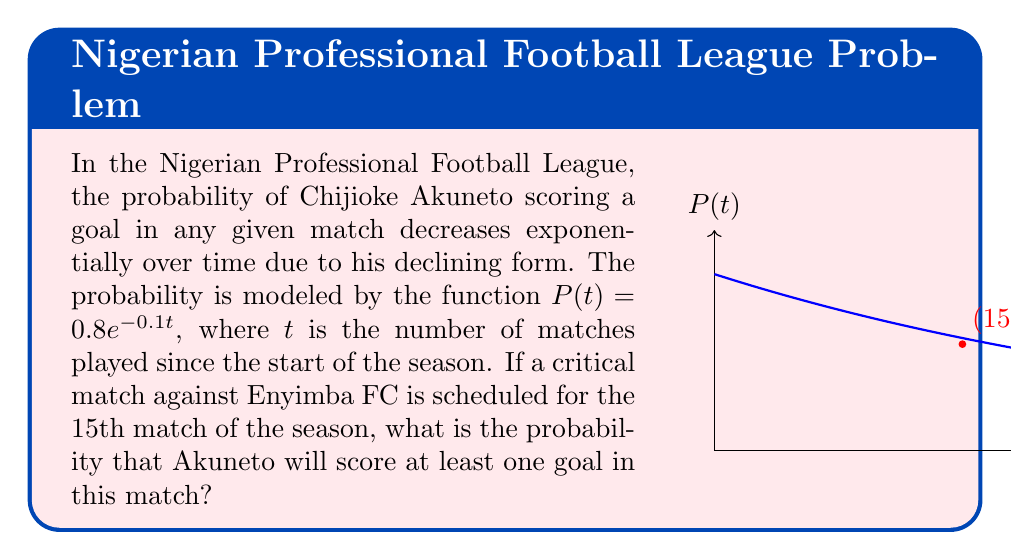Provide a solution to this math problem. Let's approach this step-by-step:

1) The probability function is given as $P(t) = 0.8e^{-0.1t}$, where $t$ is the number of matches played.

2) We need to find the probability for the 15th match, so we substitute $t = 15$ into the function:

   $P(15) = 0.8e^{-0.1(15)}$

3) Let's calculate this:
   
   $P(15) = 0.8e^{-1.5}$
   
   $P(15) = 0.8 \cdot (e^{-1.5})$
   
   $P(15) \approx 0.8 \cdot 0.2231 \approx 0.1785$

4) This gives us the probability of Akuneto scoring in the 15th match. However, the question asks for the probability of scoring at least one goal, which is the same as the probability of not scoring zero goals.

5) The probability of not scoring is the complement of the probability of scoring:

   $P(\text{at least one goal}) = 1 - P(\text{no goals})$
   
   $P(\text{at least one goal}) = 1 - (1 - 0.1785)$
   
   $P(\text{at least one goal}) = 0.1785$

6) Therefore, the probability of Akuneto scoring at least one goal in the 15th match is approximately 0.1785 or 17.85%.
Answer: $0.1785$ or $17.85\%$ 